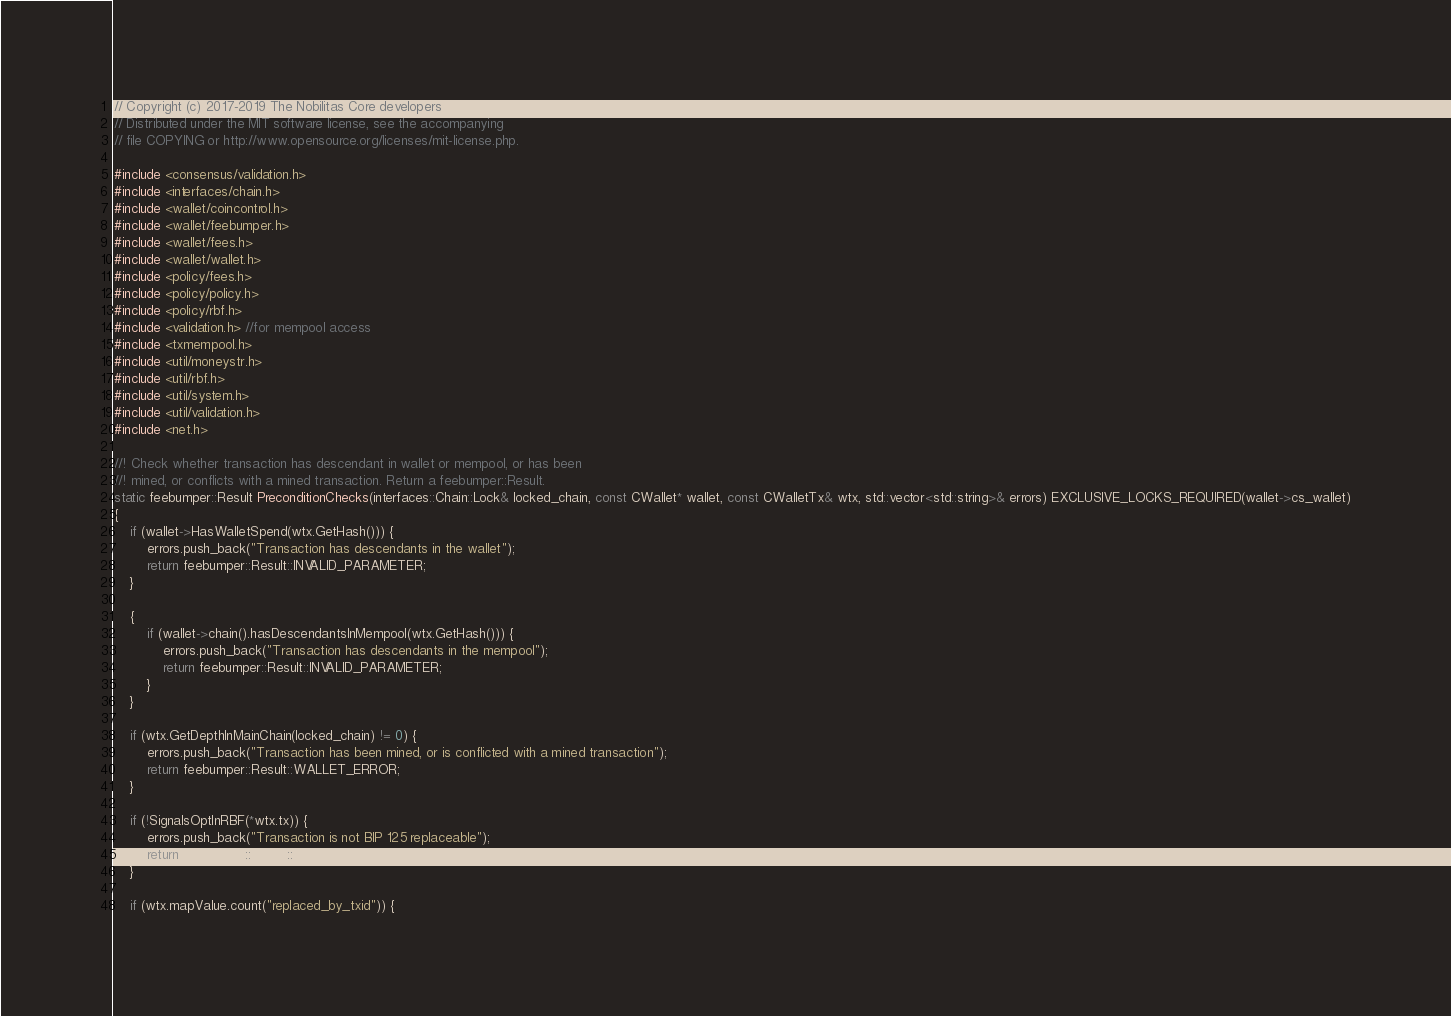<code> <loc_0><loc_0><loc_500><loc_500><_C++_>// Copyright (c) 2017-2019 The Nobilitas Core developers
// Distributed under the MIT software license, see the accompanying
// file COPYING or http://www.opensource.org/licenses/mit-license.php.

#include <consensus/validation.h>
#include <interfaces/chain.h>
#include <wallet/coincontrol.h>
#include <wallet/feebumper.h>
#include <wallet/fees.h>
#include <wallet/wallet.h>
#include <policy/fees.h>
#include <policy/policy.h>
#include <policy/rbf.h>
#include <validation.h> //for mempool access
#include <txmempool.h>
#include <util/moneystr.h>
#include <util/rbf.h>
#include <util/system.h>
#include <util/validation.h>
#include <net.h>

//! Check whether transaction has descendant in wallet or mempool, or has been
//! mined, or conflicts with a mined transaction. Return a feebumper::Result.
static feebumper::Result PreconditionChecks(interfaces::Chain::Lock& locked_chain, const CWallet* wallet, const CWalletTx& wtx, std::vector<std::string>& errors) EXCLUSIVE_LOCKS_REQUIRED(wallet->cs_wallet)
{
    if (wallet->HasWalletSpend(wtx.GetHash())) {
        errors.push_back("Transaction has descendants in the wallet");
        return feebumper::Result::INVALID_PARAMETER;
    }

    {
        if (wallet->chain().hasDescendantsInMempool(wtx.GetHash())) {
            errors.push_back("Transaction has descendants in the mempool");
            return feebumper::Result::INVALID_PARAMETER;
        }
    }

    if (wtx.GetDepthInMainChain(locked_chain) != 0) {
        errors.push_back("Transaction has been mined, or is conflicted with a mined transaction");
        return feebumper::Result::WALLET_ERROR;
    }

    if (!SignalsOptInRBF(*wtx.tx)) {
        errors.push_back("Transaction is not BIP 125 replaceable");
        return feebumper::Result::WALLET_ERROR;
    }

    if (wtx.mapValue.count("replaced_by_txid")) {</code> 